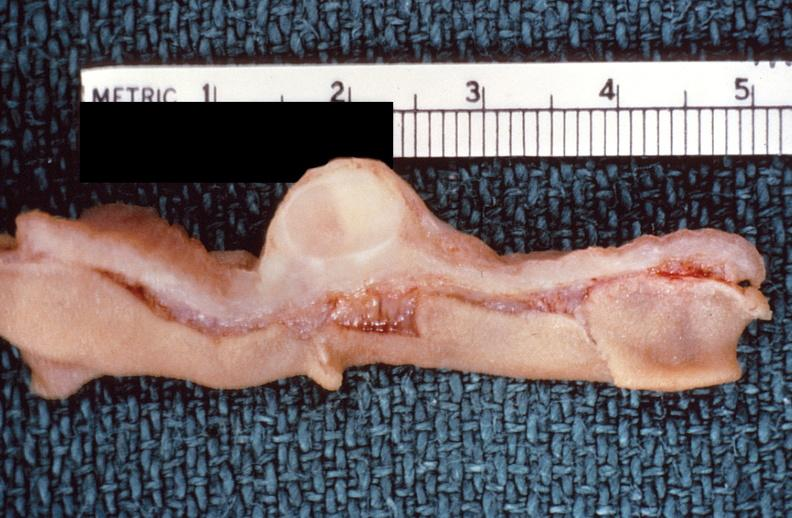s gastrointestinal present?
Answer the question using a single word or phrase. Yes 